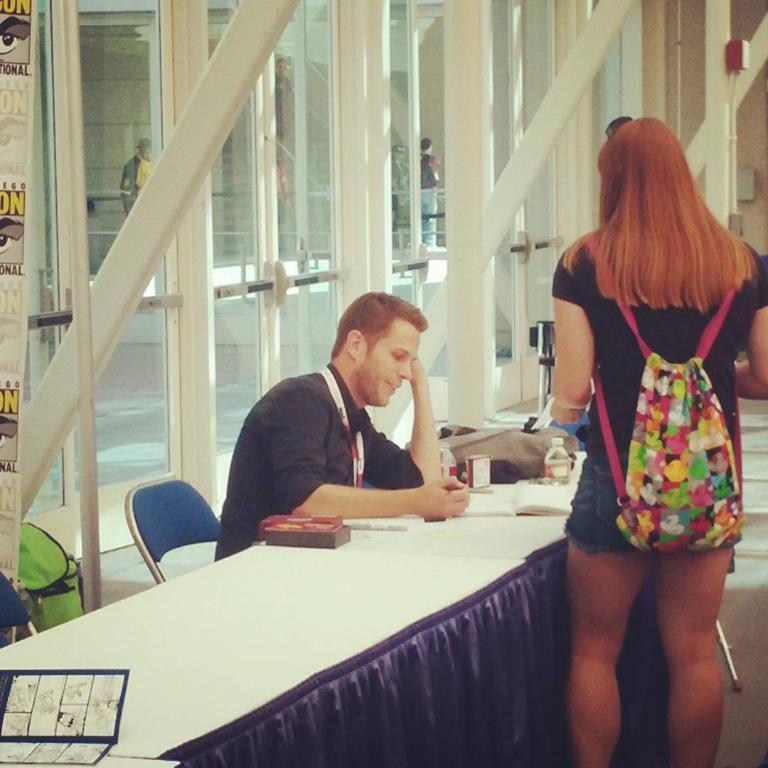How would you summarize this image in a sentence or two? This image is taken inside a room. There are two persons in this room a man and a woman, a man is sitting on a chair in the middle of the image. In the left side of the image there is a girl and a poster. In the right side of the image there is a woman standing wearing backpack. 